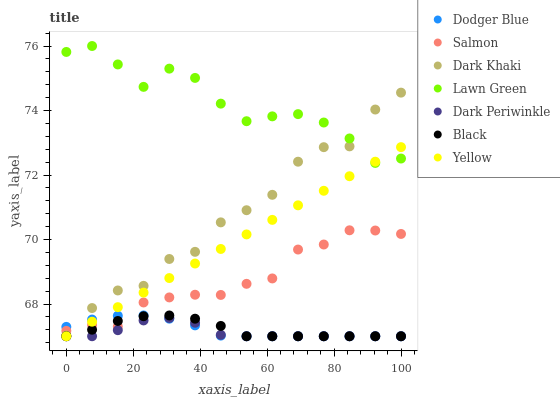Does Dark Periwinkle have the minimum area under the curve?
Answer yes or no. Yes. Does Lawn Green have the maximum area under the curve?
Answer yes or no. Yes. Does Salmon have the minimum area under the curve?
Answer yes or no. No. Does Salmon have the maximum area under the curve?
Answer yes or no. No. Is Yellow the smoothest?
Answer yes or no. Yes. Is Dark Khaki the roughest?
Answer yes or no. Yes. Is Salmon the smoothest?
Answer yes or no. No. Is Salmon the roughest?
Answer yes or no. No. Does Yellow have the lowest value?
Answer yes or no. Yes. Does Salmon have the lowest value?
Answer yes or no. No. Does Lawn Green have the highest value?
Answer yes or no. Yes. Does Salmon have the highest value?
Answer yes or no. No. Is Salmon less than Lawn Green?
Answer yes or no. Yes. Is Lawn Green greater than Dodger Blue?
Answer yes or no. Yes. Does Dark Khaki intersect Salmon?
Answer yes or no. Yes. Is Dark Khaki less than Salmon?
Answer yes or no. No. Is Dark Khaki greater than Salmon?
Answer yes or no. No. Does Salmon intersect Lawn Green?
Answer yes or no. No. 